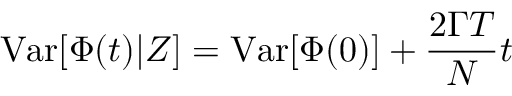<formula> <loc_0><loc_0><loc_500><loc_500>{ V a r } [ \Phi ( t ) | Z ] = { V a r } [ \Phi ( 0 ) ] + \frac { 2 \Gamma T } { N } t</formula> 